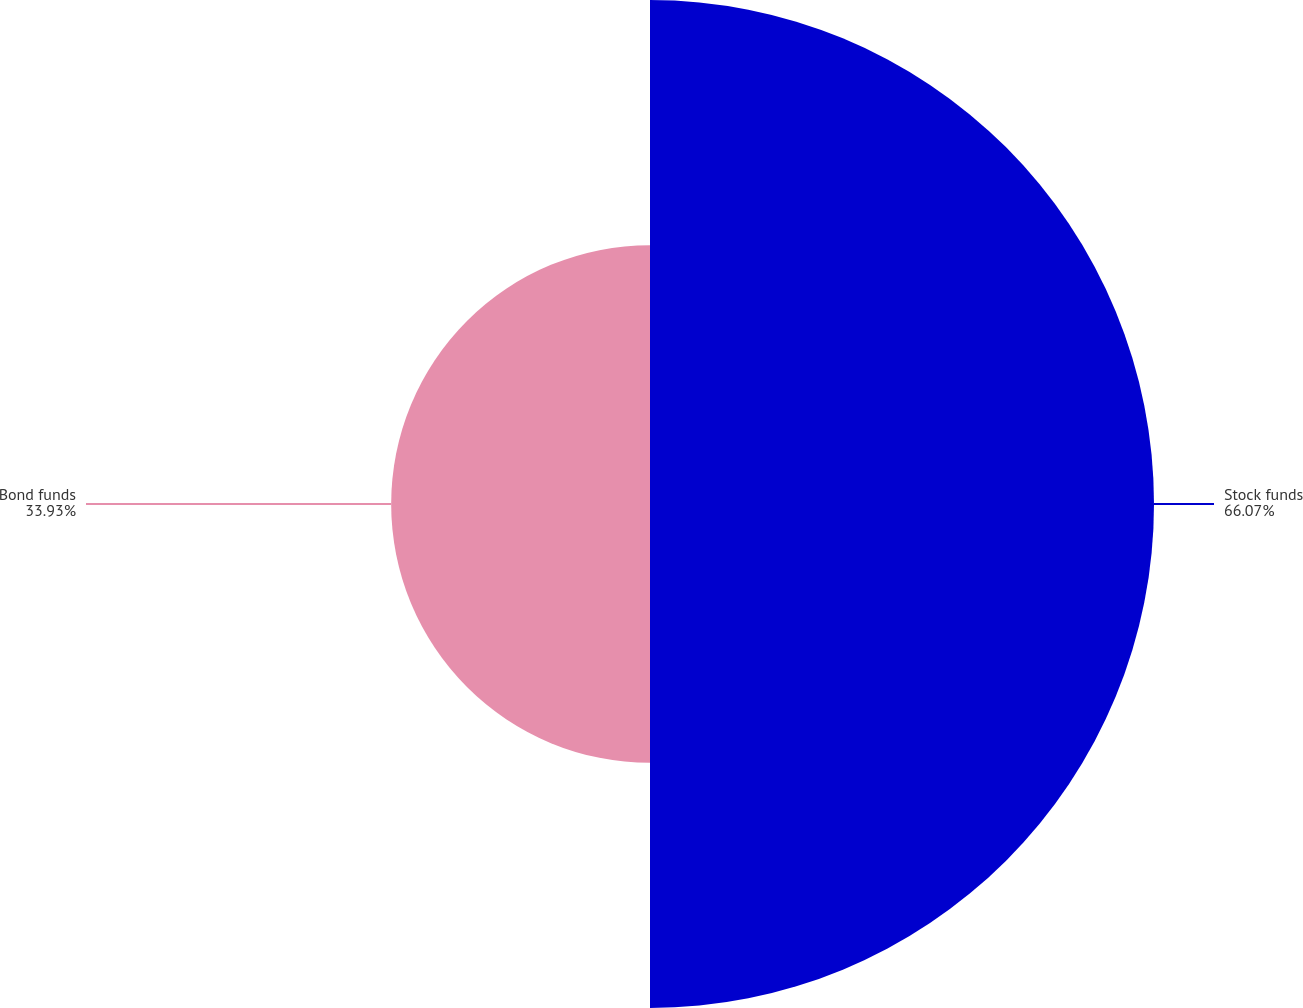<chart> <loc_0><loc_0><loc_500><loc_500><pie_chart><fcel>Stock funds<fcel>Bond funds<nl><fcel>66.07%<fcel>33.93%<nl></chart> 